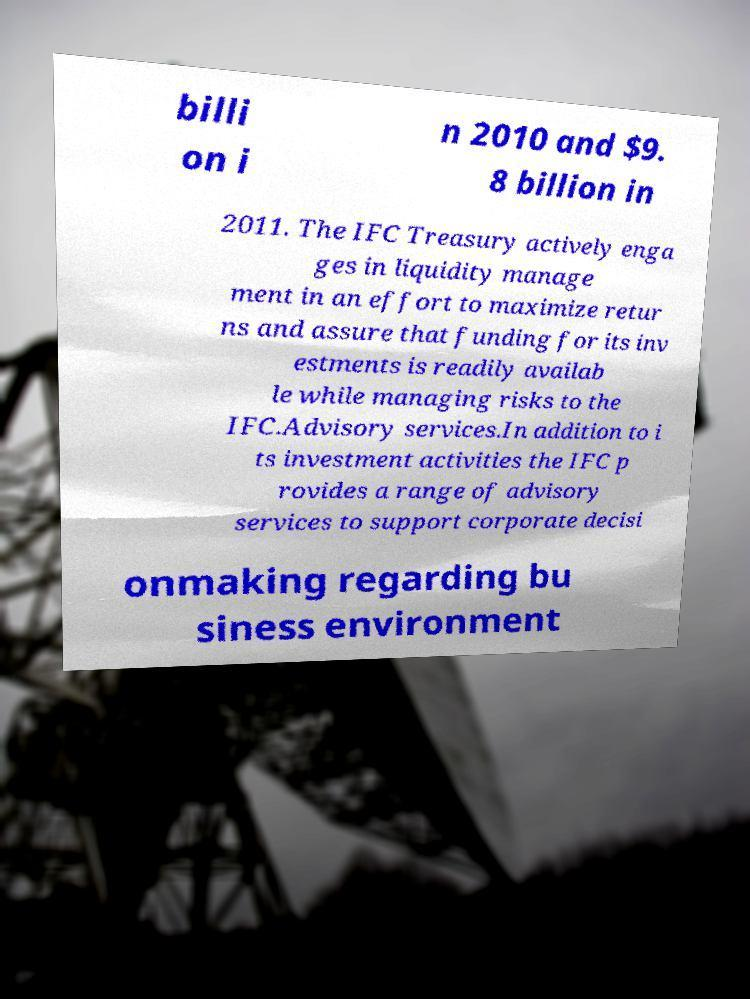For documentation purposes, I need the text within this image transcribed. Could you provide that? billi on i n 2010 and $9. 8 billion in 2011. The IFC Treasury actively enga ges in liquidity manage ment in an effort to maximize retur ns and assure that funding for its inv estments is readily availab le while managing risks to the IFC.Advisory services.In addition to i ts investment activities the IFC p rovides a range of advisory services to support corporate decisi onmaking regarding bu siness environment 